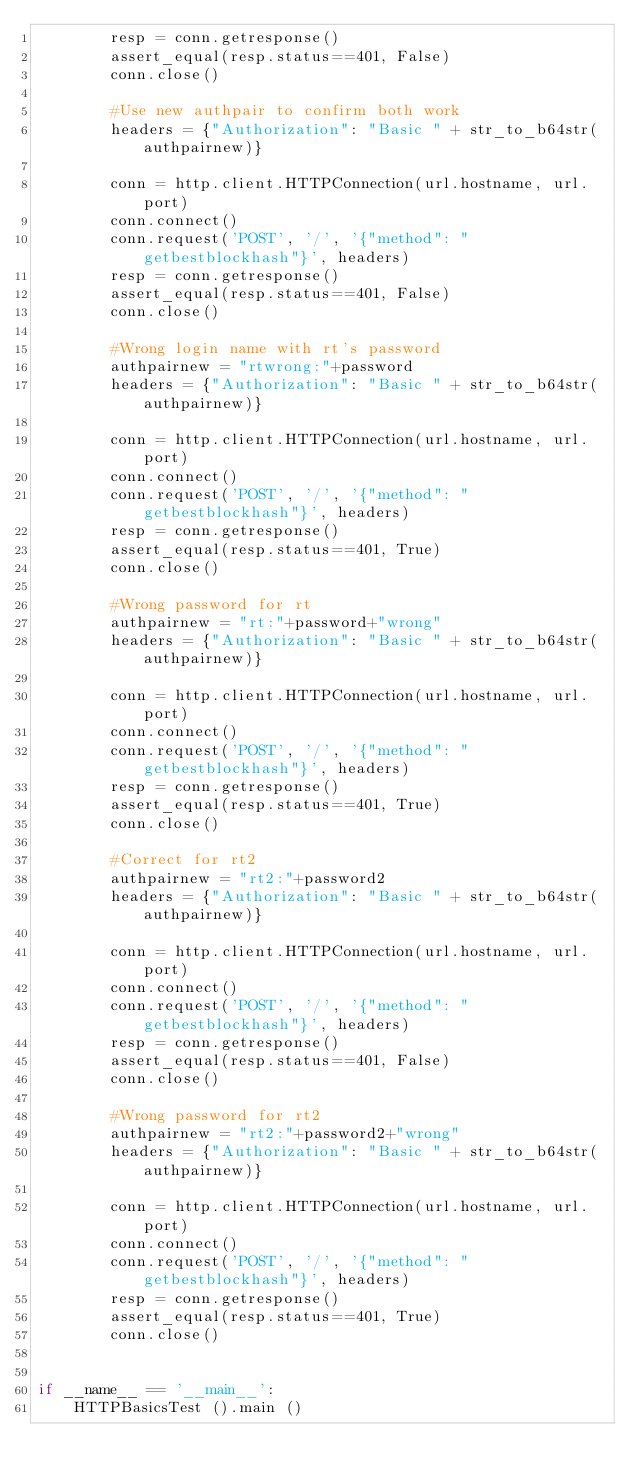Convert code to text. <code><loc_0><loc_0><loc_500><loc_500><_Python_>        resp = conn.getresponse()
        assert_equal(resp.status==401, False)
        conn.close()
        
        #Use new authpair to confirm both work
        headers = {"Authorization": "Basic " + str_to_b64str(authpairnew)}

        conn = http.client.HTTPConnection(url.hostname, url.port)
        conn.connect()
        conn.request('POST', '/', '{"method": "getbestblockhash"}', headers)
        resp = conn.getresponse()
        assert_equal(resp.status==401, False)
        conn.close()

        #Wrong login name with rt's password
        authpairnew = "rtwrong:"+password
        headers = {"Authorization": "Basic " + str_to_b64str(authpairnew)}

        conn = http.client.HTTPConnection(url.hostname, url.port)
        conn.connect()
        conn.request('POST', '/', '{"method": "getbestblockhash"}', headers)
        resp = conn.getresponse()
        assert_equal(resp.status==401, True)
        conn.close()

        #Wrong password for rt
        authpairnew = "rt:"+password+"wrong"
        headers = {"Authorization": "Basic " + str_to_b64str(authpairnew)}

        conn = http.client.HTTPConnection(url.hostname, url.port)
        conn.connect()
        conn.request('POST', '/', '{"method": "getbestblockhash"}', headers)
        resp = conn.getresponse()
        assert_equal(resp.status==401, True)
        conn.close()

        #Correct for rt2
        authpairnew = "rt2:"+password2
        headers = {"Authorization": "Basic " + str_to_b64str(authpairnew)}

        conn = http.client.HTTPConnection(url.hostname, url.port)
        conn.connect()
        conn.request('POST', '/', '{"method": "getbestblockhash"}', headers)
        resp = conn.getresponse()
        assert_equal(resp.status==401, False)
        conn.close()

        #Wrong password for rt2
        authpairnew = "rt2:"+password2+"wrong"
        headers = {"Authorization": "Basic " + str_to_b64str(authpairnew)}

        conn = http.client.HTTPConnection(url.hostname, url.port)
        conn.connect()
        conn.request('POST', '/', '{"method": "getbestblockhash"}', headers)
        resp = conn.getresponse()
        assert_equal(resp.status==401, True)
        conn.close()


if __name__ == '__main__':
    HTTPBasicsTest ().main ()
</code> 